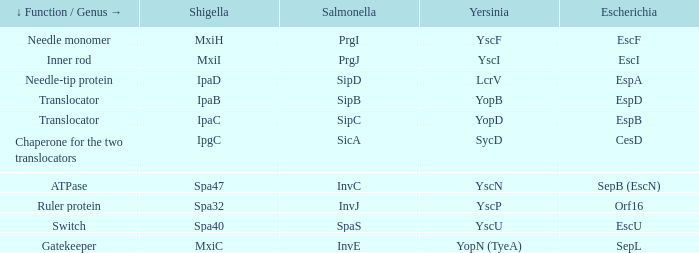Tell me the shigella for yersinia yopb IpaB. 